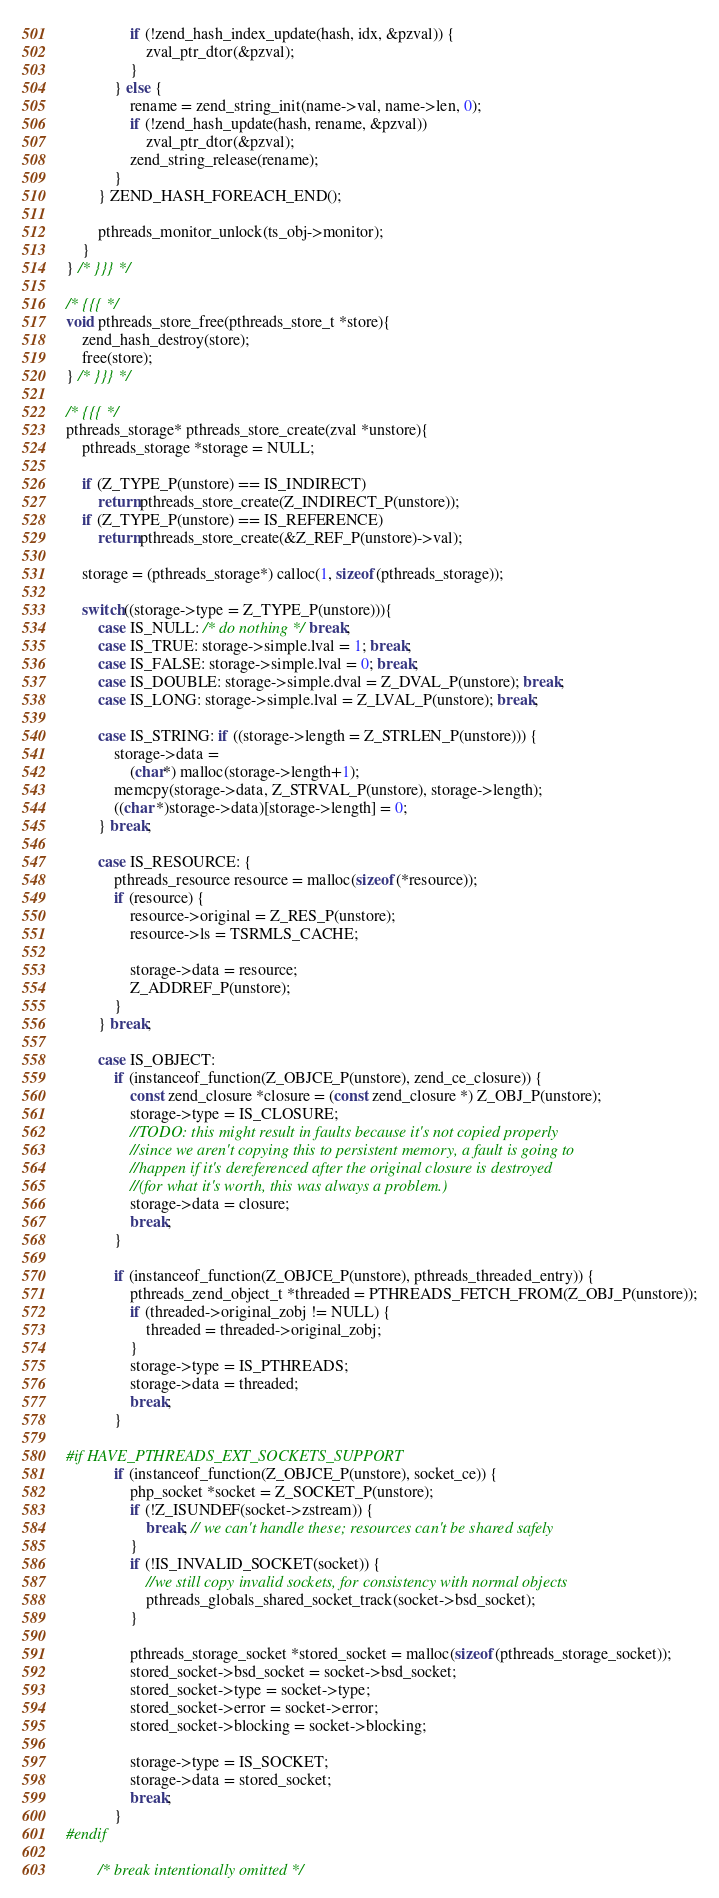<code> <loc_0><loc_0><loc_500><loc_500><_C_>				if (!zend_hash_index_update(hash, idx, &pzval)) {
					zval_ptr_dtor(&pzval);
				}
			} else {
				rename = zend_string_init(name->val, name->len, 0);
				if (!zend_hash_update(hash, rename, &pzval))
					zval_ptr_dtor(&pzval);
				zend_string_release(rename);
			}
		} ZEND_HASH_FOREACH_END();

		pthreads_monitor_unlock(ts_obj->monitor);
	}
} /* }}} */

/* {{{ */
void pthreads_store_free(pthreads_store_t *store){
	zend_hash_destroy(store);
	free(store);
} /* }}} */

/* {{{ */
pthreads_storage* pthreads_store_create(zval *unstore){
	pthreads_storage *storage = NULL;

	if (Z_TYPE_P(unstore) == IS_INDIRECT)
		return pthreads_store_create(Z_INDIRECT_P(unstore));
	if (Z_TYPE_P(unstore) == IS_REFERENCE)
		return pthreads_store_create(&Z_REF_P(unstore)->val);

	storage = (pthreads_storage*) calloc(1, sizeof(pthreads_storage));

	switch((storage->type = Z_TYPE_P(unstore))){
		case IS_NULL: /* do nothing */ break;
		case IS_TRUE: storage->simple.lval = 1; break;
		case IS_FALSE: storage->simple.lval = 0; break;
		case IS_DOUBLE: storage->simple.dval = Z_DVAL_P(unstore); break;
		case IS_LONG: storage->simple.lval = Z_LVAL_P(unstore); break;

		case IS_STRING: if ((storage->length = Z_STRLEN_P(unstore))) {
			storage->data =
				(char*) malloc(storage->length+1);
			memcpy(storage->data, Z_STRVAL_P(unstore), storage->length);
			((char *)storage->data)[storage->length] = 0;
		} break;

		case IS_RESOURCE: {
			pthreads_resource resource = malloc(sizeof(*resource));
			if (resource) {
				resource->original = Z_RES_P(unstore);
				resource->ls = TSRMLS_CACHE;

				storage->data = resource;
				Z_ADDREF_P(unstore);
			}
		} break;

		case IS_OBJECT:
			if (instanceof_function(Z_OBJCE_P(unstore), zend_ce_closure)) {
				const zend_closure *closure = (const zend_closure *) Z_OBJ_P(unstore);
				storage->type = IS_CLOSURE;
				//TODO: this might result in faults because it's not copied properly
				//since we aren't copying this to persistent memory, a fault is going to
				//happen if it's dereferenced after the original closure is destroyed
				//(for what it's worth, this was always a problem.)
				storage->data = closure;
				break;
			}

			if (instanceof_function(Z_OBJCE_P(unstore), pthreads_threaded_entry)) {
				pthreads_zend_object_t *threaded = PTHREADS_FETCH_FROM(Z_OBJ_P(unstore));
				if (threaded->original_zobj != NULL) {
					threaded = threaded->original_zobj;
				}
				storage->type = IS_PTHREADS;
				storage->data = threaded;
				break;
			}

#if HAVE_PTHREADS_EXT_SOCKETS_SUPPORT
			if (instanceof_function(Z_OBJCE_P(unstore), socket_ce)) {
				php_socket *socket = Z_SOCKET_P(unstore);
				if (!Z_ISUNDEF(socket->zstream)) {
					break; // we can't handle these; resources can't be shared safely
				}
				if (!IS_INVALID_SOCKET(socket)) {
					//we still copy invalid sockets, for consistency with normal objects
					pthreads_globals_shared_socket_track(socket->bsd_socket);
				}

				pthreads_storage_socket *stored_socket = malloc(sizeof(pthreads_storage_socket));
				stored_socket->bsd_socket = socket->bsd_socket;
				stored_socket->type = socket->type;
				stored_socket->error = socket->error;
				stored_socket->blocking = socket->blocking;

				storage->type = IS_SOCKET;
				storage->data = stored_socket;
				break;
			}
#endif

		/* break intentionally omitted */</code> 